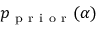Convert formula to latex. <formula><loc_0><loc_0><loc_500><loc_500>p _ { p r i o r } ( \alpha )</formula> 